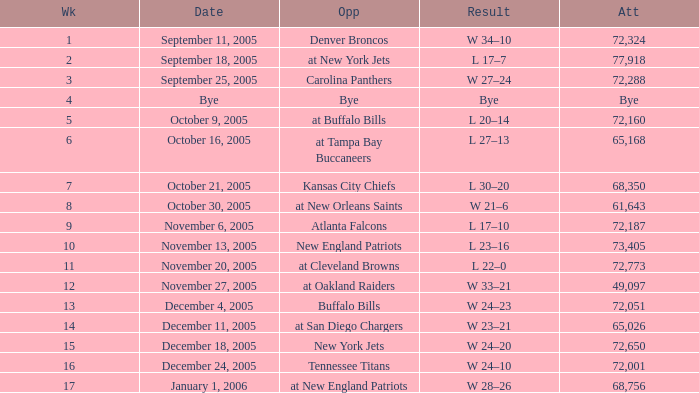What is the Week with a Date of Bye? 1.0. 